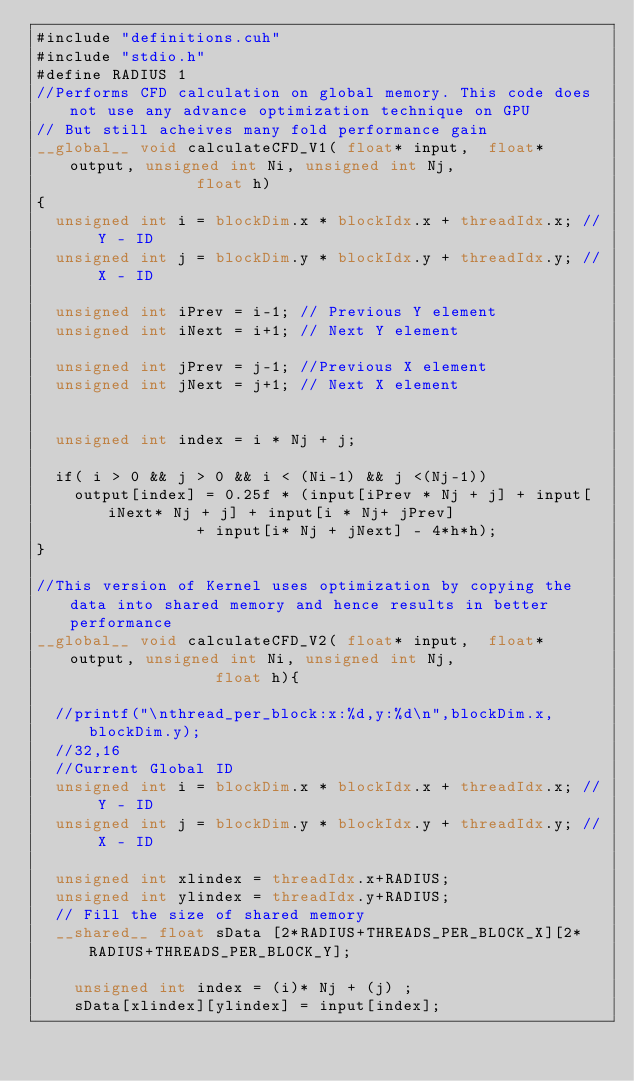<code> <loc_0><loc_0><loc_500><loc_500><_Cuda_>#include "definitions.cuh"
#include "stdio.h"
#define RADIUS 1
//Performs CFD calculation on global memory. This code does not use any advance optimization technique on GPU
// But still acheives many fold performance gain
__global__ void calculateCFD_V1( float* input,  float* output, unsigned int Ni, unsigned int Nj,
								 float h)
{
	unsigned int i = blockDim.x * blockIdx.x + threadIdx.x; // Y - ID
	unsigned int j = blockDim.y * blockIdx.y + threadIdx.y; // X - ID

	unsigned int iPrev = i-1; // Previous Y element
	unsigned int iNext = i+1; // Next Y element

	unsigned int jPrev = j-1; //Previous X element
	unsigned int jNext = j+1; // Next X element


	unsigned int index = i * Nj + j;

	if( i > 0 && j > 0 && i < (Ni-1) && j <(Nj-1))
		output[index] = 0.25f * (input[iPrev * Nj + j] + input[iNext* Nj + j] + input[i * Nj+ jPrev]
								 + input[i* Nj + jNext] - 4*h*h);
}

//This version of Kernel uses optimization by copying the data into shared memory and hence results in better performance
__global__ void calculateCFD_V2( float* input,  float* output, unsigned int Ni, unsigned int Nj, 
								   float h){

	//printf("\nthread_per_block:x:%d,y:%d\n",blockDim.x,blockDim.y);
	//32,16
	//Current Global ID
	unsigned int i = blockDim.x * blockIdx.x + threadIdx.x; // Y - ID
	unsigned int j = blockDim.y * blockIdx.y + threadIdx.y; // X - ID

	unsigned int xlindex = threadIdx.x+RADIUS;
	unsigned int ylindex = threadIdx.y+RADIUS;
	// Fill the size of shared memory
	__shared__ float sData [2*RADIUS+THREADS_PER_BLOCK_X][2*RADIUS+THREADS_PER_BLOCK_Y];

    unsigned int index = (i)* Nj + (j) ;
    sData[xlindex][ylindex] = input[index];
</code> 